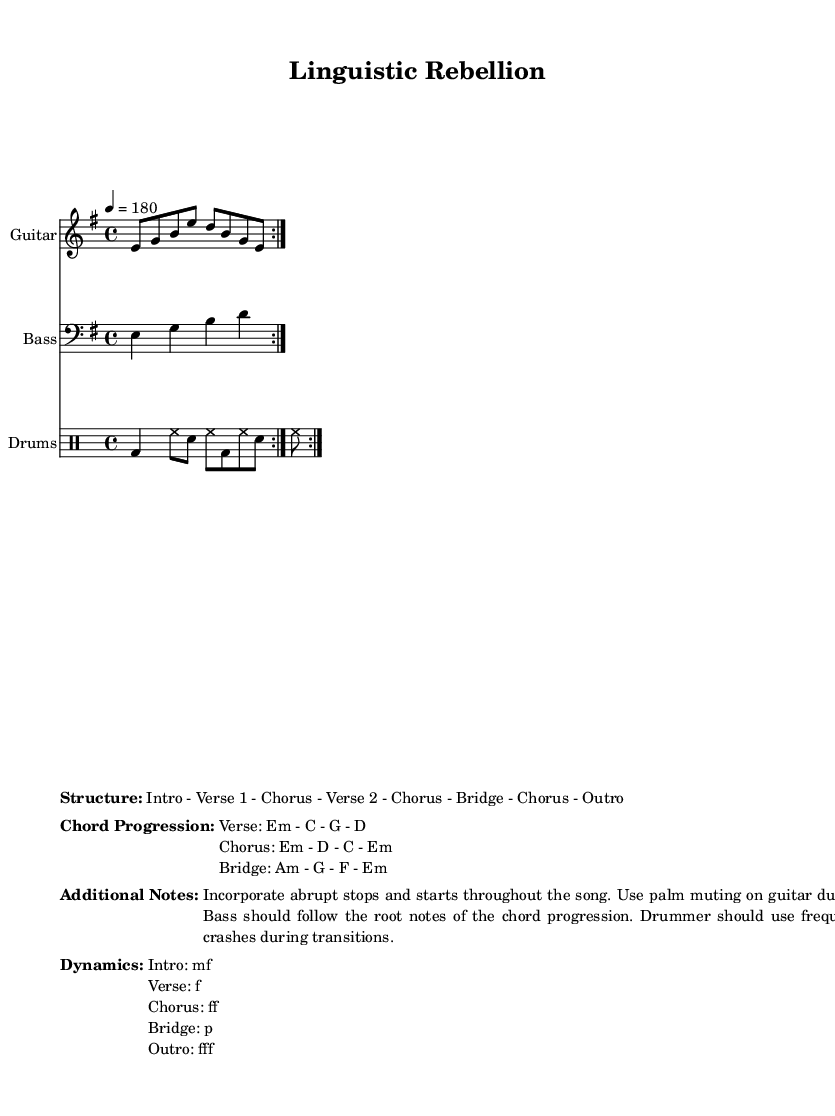What is the key signature of this music? The key signature is E minor, which has one sharp (F#). This can be determined by looking at the beginning of the sheet music.
Answer: E minor What is the time signature of this music? The time signature is 4/4, which indicates there are four beats in each measure and that the quarter note gets one beat. This information is typically found at the beginning of the piece.
Answer: 4/4 What is the tempo of the music? The tempo is set at 180 beats per minute, indicated by the marking '4 = 180' at the start. This indicates the speed at which the piece should be played.
Answer: 180 What is the structure of the performance? The structure includes sections such as Intro, Verse 1, Chorus, Verse 2, Bridge, and Outro. This organization of sections can be found within the sheet music under the markup section titled "Structure."
Answer: Intro - Verse 1 - Chorus - Verse 2 - Chorus - Bridge - Chorus - Outro What is the chord progression for the chorus? The chord progression for the chorus is Em - D - C - Em, which can be found under the markup titled "Chord Progression." This indicates the specific chords to play during that section.
Answer: Em - D - C - Em How should the dynamics change during the bridge? The dynamics during the bridge should be played softly, indicated by 'p' (piano). This can be found in the Dynamics markup section where each section's dynamics are noted.
Answer: p What specific playing technique is suggested for the guitar during verses? The sheet suggests using palm muting on the guitar during verses, which can be found in the "Additional Notes" section that provides performance instructions.
Answer: Palm muting 